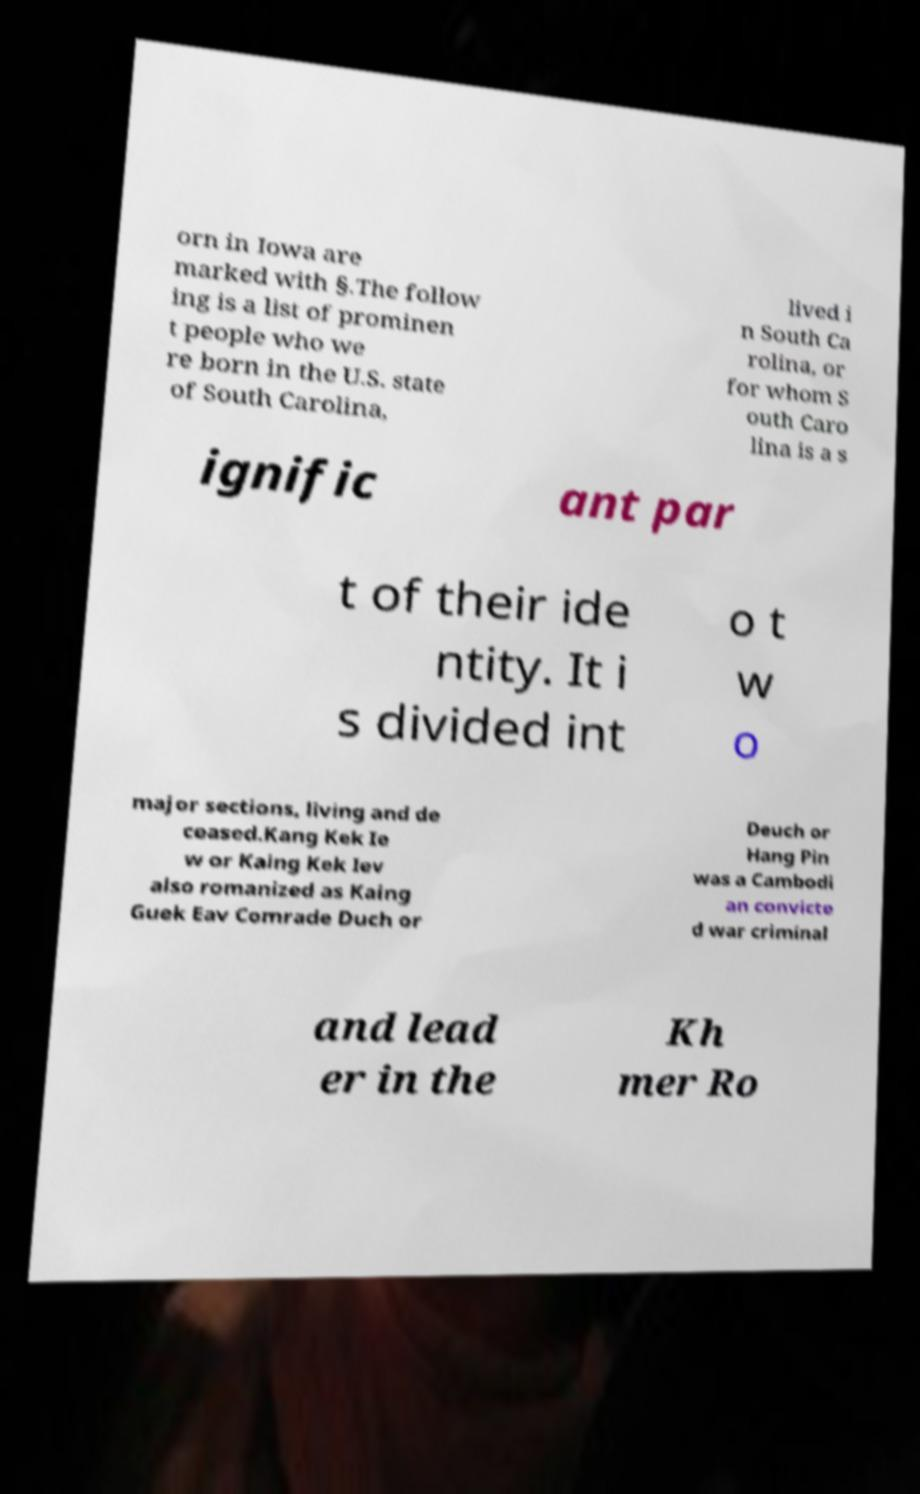Can you read and provide the text displayed in the image?This photo seems to have some interesting text. Can you extract and type it out for me? orn in Iowa are marked with §.The follow ing is a list of prominen t people who we re born in the U.S. state of South Carolina, lived i n South Ca rolina, or for whom S outh Caro lina is a s ignific ant par t of their ide ntity. It i s divided int o t w o major sections, living and de ceased.Kang Kek Ie w or Kaing Kek Iev also romanized as Kaing Guek Eav Comrade Duch or Deuch or Hang Pin was a Cambodi an convicte d war criminal and lead er in the Kh mer Ro 